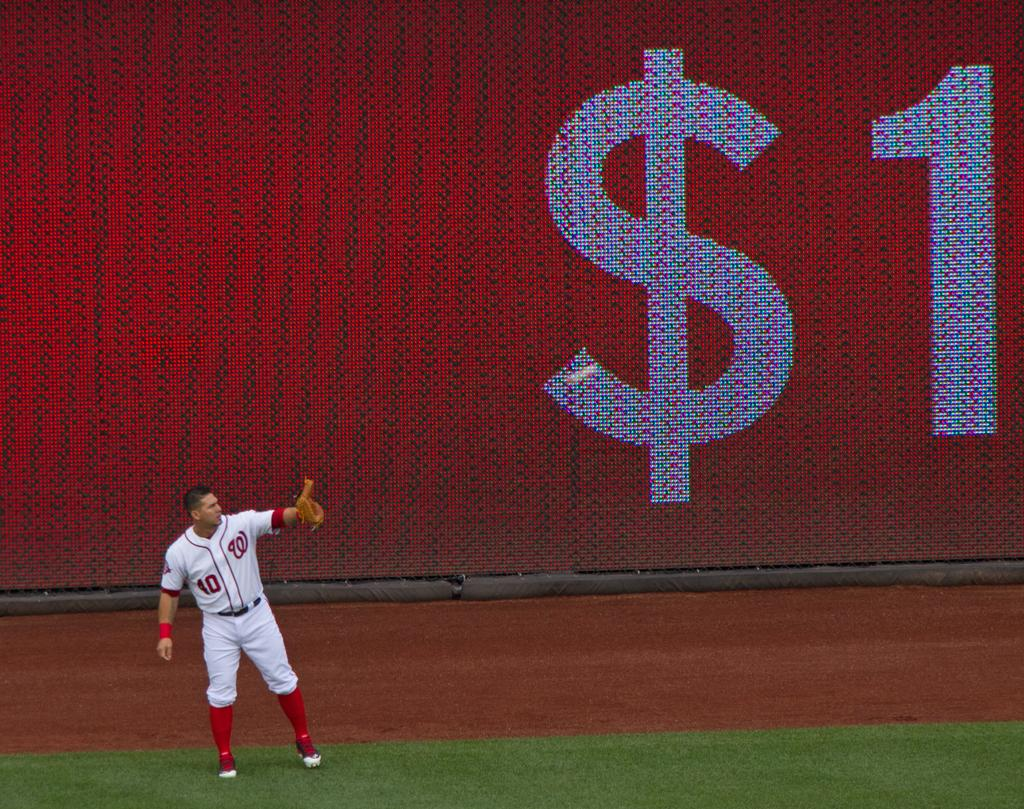Provide a one-sentence caption for the provided image. Number 40 baseball catcher with the Washington Nationals team lifting up his mitt to catch a ball. 